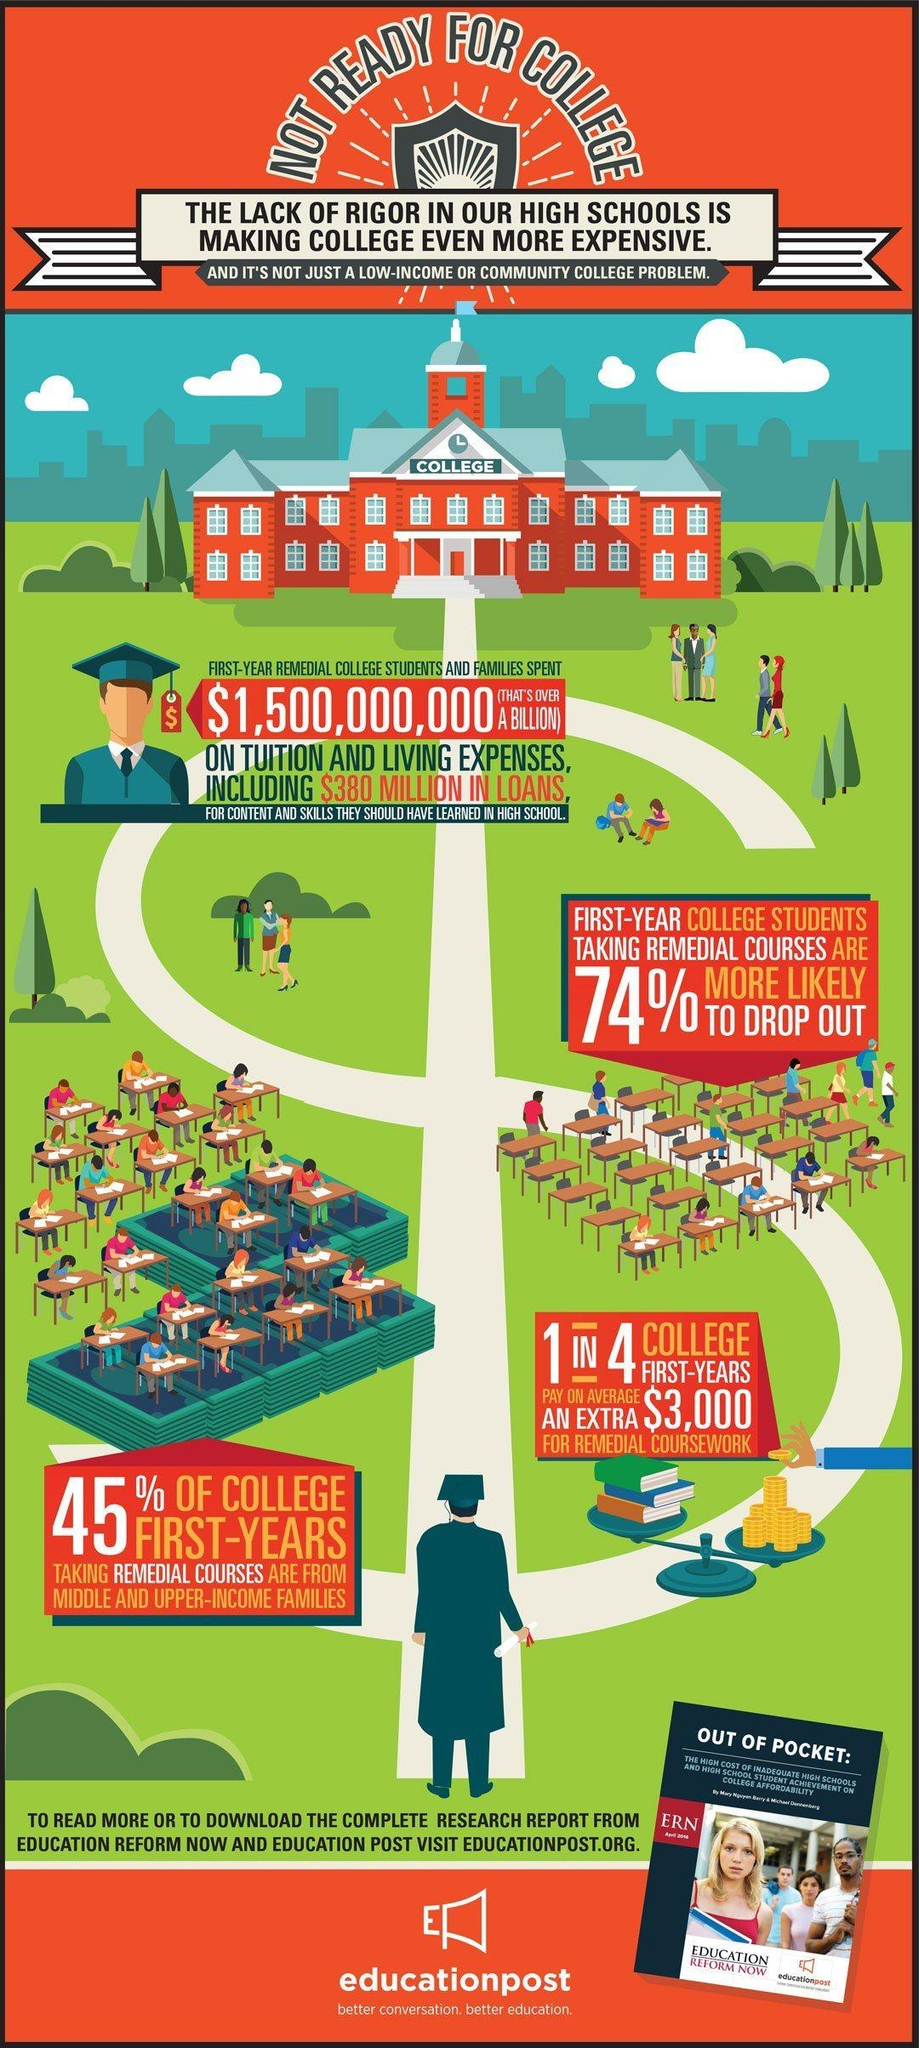Identify some key points in this picture. A significant percentage of first-year students taking remedial classes are not likely to drop out, with 26% being the case. First-year remedial college students and their families had to spend over a billion dollars on tuition and living expenses. In total, college students and their families borrowed $380 million in loans. On average, students spend approximately $3,000 on remedial coursework. 